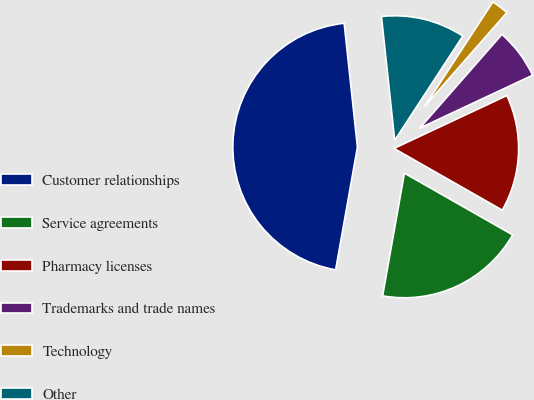<chart> <loc_0><loc_0><loc_500><loc_500><pie_chart><fcel>Customer relationships<fcel>Service agreements<fcel>Pharmacy licenses<fcel>Trademarks and trade names<fcel>Technology<fcel>Other<nl><fcel>45.5%<fcel>19.55%<fcel>15.22%<fcel>6.57%<fcel>2.25%<fcel>10.9%<nl></chart> 